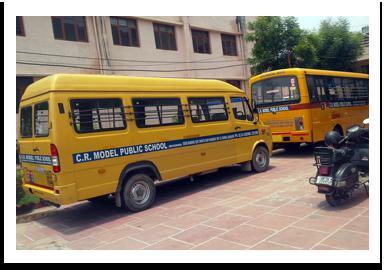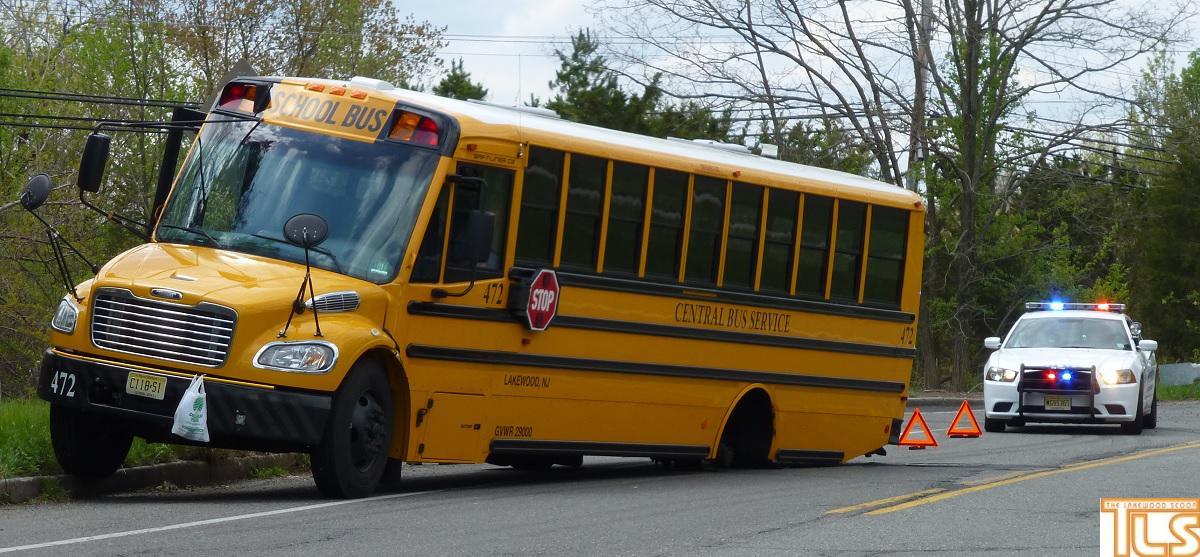The first image is the image on the left, the second image is the image on the right. Analyze the images presented: Is the assertion "the left and right image contains the same number of buses." valid? Answer yes or no. No. 